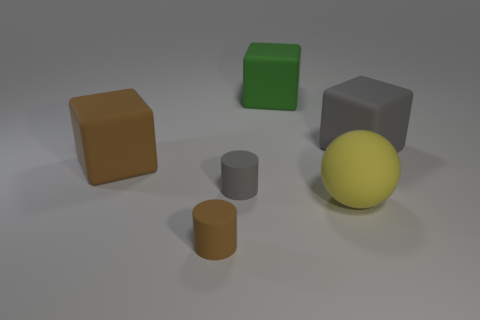What is the shape of the gray object behind the tiny gray cylinder?
Offer a very short reply. Cube. What number of things are both left of the yellow ball and to the right of the green thing?
Ensure brevity in your answer.  0. There is a gray block; is its size the same as the block that is in front of the large gray rubber object?
Your answer should be compact. Yes. There is a gray rubber thing to the right of the gray rubber thing that is in front of the large matte object to the right of the big yellow matte object; how big is it?
Offer a terse response. Large. What size is the gray object on the left side of the big green rubber object?
Your answer should be compact. Small. The small gray thing that is the same material as the tiny brown cylinder is what shape?
Provide a short and direct response. Cylinder. Does the big cube behind the big gray cube have the same material as the brown cylinder?
Provide a short and direct response. Yes. How many other things are made of the same material as the large ball?
Provide a short and direct response. 5. What number of objects are large blocks to the right of the big rubber sphere or objects that are on the left side of the yellow matte object?
Make the answer very short. 5. Does the thing behind the large gray thing have the same shape as the large object to the left of the gray rubber cylinder?
Provide a short and direct response. Yes. 